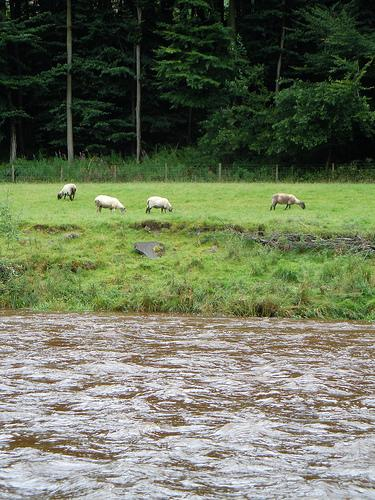Identify the most noticeable natural element in the picture and describe its appearance. The big brown river is the most noticeable natural element, with ripples in the water and surrounded by grass and rocks. Examine the image and describe any possible interactions between objects. The sheep interact with the grassy field as they graze, and the river flows close to the grass and rocks, potentially providing water for the sheep. Describe any interesting texture present in the image. The ripples in the big brown river create an interesting texture in the image. Estimate the total number of sheep in the image. It is difficult to pinpoint an exact number, but there are at least four sheep in the image, possibly more. Count the number of sheep legs present in the image. There are 16 sheep legs present in the image. Point out any small details that are not part of the main focus of the image. There are brown twigs, a small wire fence, a long brown tree trunk, and a group of green trees in the background. Analyze the sentiment conveyed by the image. The image conveys a calm and peaceful sentiment, as the sheep graze leisurely in the grassy field near the river. What is the main activity happening in the scene? A group of sheep are grazing in a grassy field near a big brown river. What separates the sheep from the river in the image? A field of grass and some rocks separate the sheep from the river. Provide a brief description of the main objects in the image. There is a group of sheep in a grassy field, a big brown river with ripples, a large rock, and some trees in the background. Rate the image quality on a scale of 1 to 10. 8 Does the image contain any text or written words? No Write a short caption describing the scene. A group of sheep grazing peacefully in a grassy field near a river. Are there any trees in the image, if yes, describe them. Yes, there is a long brown tree trunk and a group of green trees. Identify the location of the large rock in the ground. X:126 Y:241 Width:48 Height:48 Quote the location and measurement of ripples in the river. X:64 Y:435 Width:60 Height:60 State the position of the green grass in the field. X:49 Y:229 Width:248 Height:248 What is the main activity of the sheep in the image? Eating grass in the field List all the objects present in the image. A group of sheep, ripples in a river, a big brown river, the coast of a river, a big field of grass, a large rock, a bunch of brown twigs, a long brown tree trunk, a small wire fence, the head of a sheep, green grass, a sheep eating, legs of sheep, a clear view of water, a group of stones, and a group of green trees. What is the dominant color of the grass in the field? Green Locate the head of a sheep in the image. X:117 Y:195 Width:12 Height:12 Describe the overall sentiment of the image. Peaceful, serene, and natural. Identify any unusual objects or anomalies in the image. No unusual objects or anomalies detected. How many legs of a sheep are visible in the image? 14 What is the primary geographical feature of the image? A riverside grassy field with sheep grazing Describe the attributes of the river in the image. big, brown, with visible ripples, and gentle flowing. What is the most prominent object in the image? A group of sheep What kind of interaction is happening between the sheep and their environment? The sheep are eating grass and interacting with the grassy field. What is the position of the small wire fence in the image? X:123 Y:160 Width:138 Height:138 Can you find the position of the water flowing near the grass? X:34 Y:310 Width:315 Height:315 